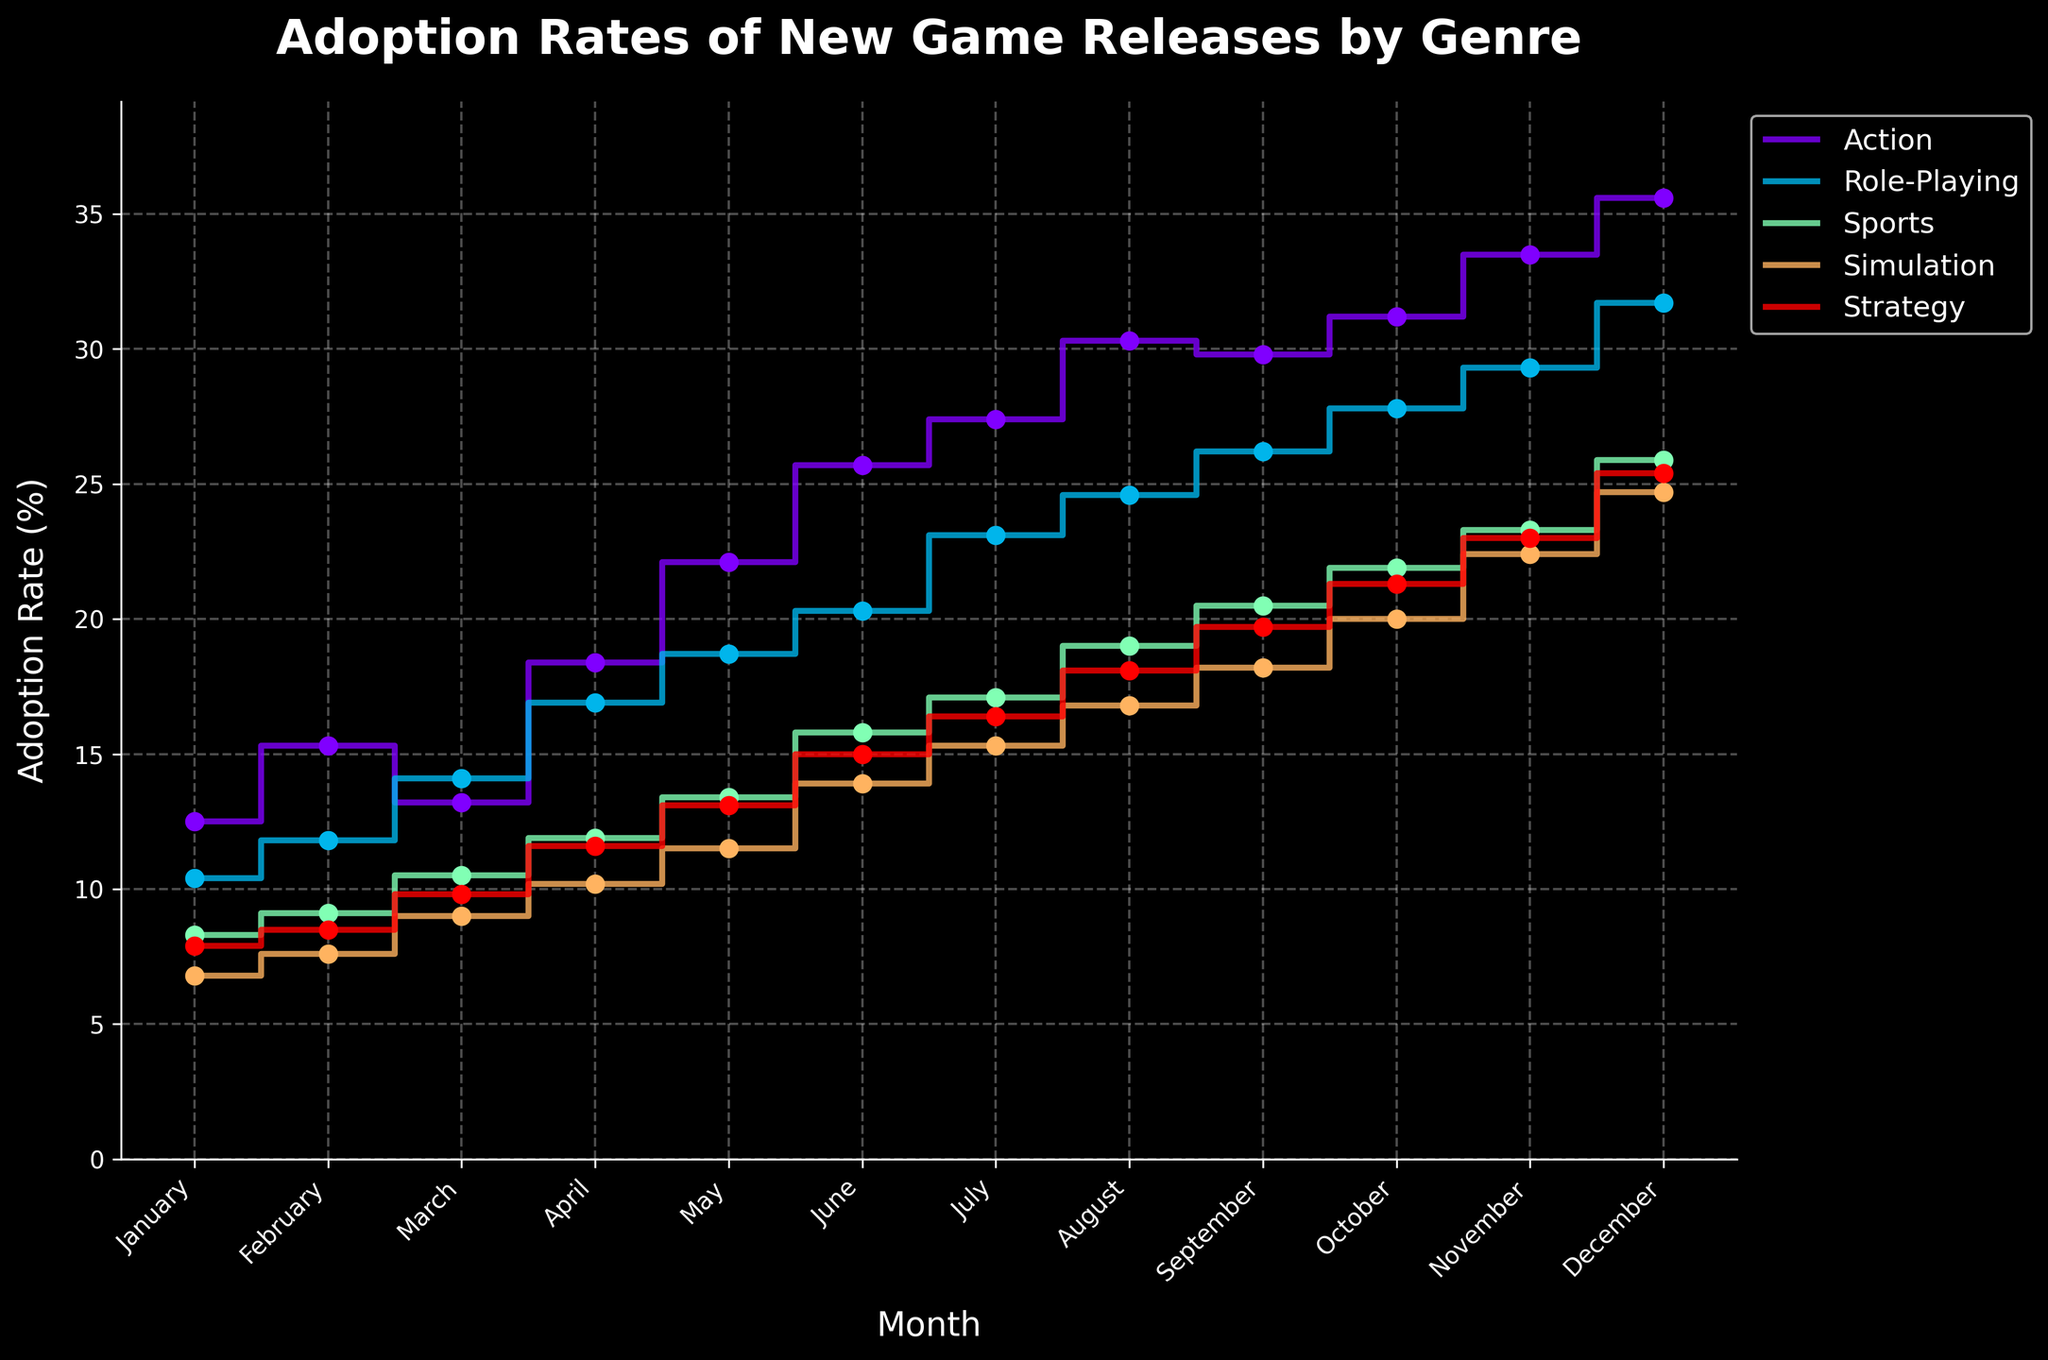What is the title of the figure? The title of the figure is located at the top and is prominently displayed in bold font.
Answer: Adoption Rates of New Game Releases by Genre Which genre has the highest adoption rate in December? By examining the data points for December on the plot, we can see which genre has the highest value on the y-axis.
Answer: Action What is the adoption rate for the Simulation genre in April? Find the data point corresponding to April for the Simulation genre, which is denoted by the respective color and shape on the plot.
Answer: 10.2% Which genre shows the highest increase in adoption rate from January to December? Calculate the difference in adoption rate from January to December for each genre and compare the results to find which one is the greatest. Action: 35.6 - 12.5 = 23.1, Role-Playing: 31.7 - 10.4 = 21.3, Sports: 25.9 - 8.3 = 17.6, Simulation: 24.7 - 6.8 = 17.9, Strategy: 25.4 - 7.9 = 17.5.
Answer: Action During which month do all genres show an increase in adoption rate compared to the previous month? Compare the adoption rates month by month for each genre. Identify a month where all genres have an adoption rate higher than the previous month.
Answer: May What is the average adoption rate for Role-Playing games from January to December? Add the monthly adoption rates for the Role-Playing genre and divide by 12 (the number of months). (10.4 + 11.8 + 14.1 + 16.9 + 18.7 + 20.3 + 23.1 + 24.6 + 26.2 + 27.8 + 29.3 + 31.7) / 12 = 206.9 / 12
Answer: 17.2% Which genre's adoption rate fluctuates the most over the year? Calculate the range (difference between the maximum and minimum adoption rates) for each genre, and compare them. Action: 35.6 - 12.5 = 23.1, Role-Playing: 31.7 - 10.4 = 21.3, Sports: 25.9 - 8.3 = 17.6, Simulation: 24.7 - 6.8 = 17.9, Strategy: 25.4 - 7.9 = 17.5.
Answer: Action In which month does the Strategy genre first reach an adoption rate above 20%? Check the adoption rates for each month for the Strategy genre until it surpasses 20%.
Answer: October Which genre has the lowest adoption rate in September? Compare the adoption rates for each genre in September by examining the corresponding data points on the plot.
Answer: Simulation 